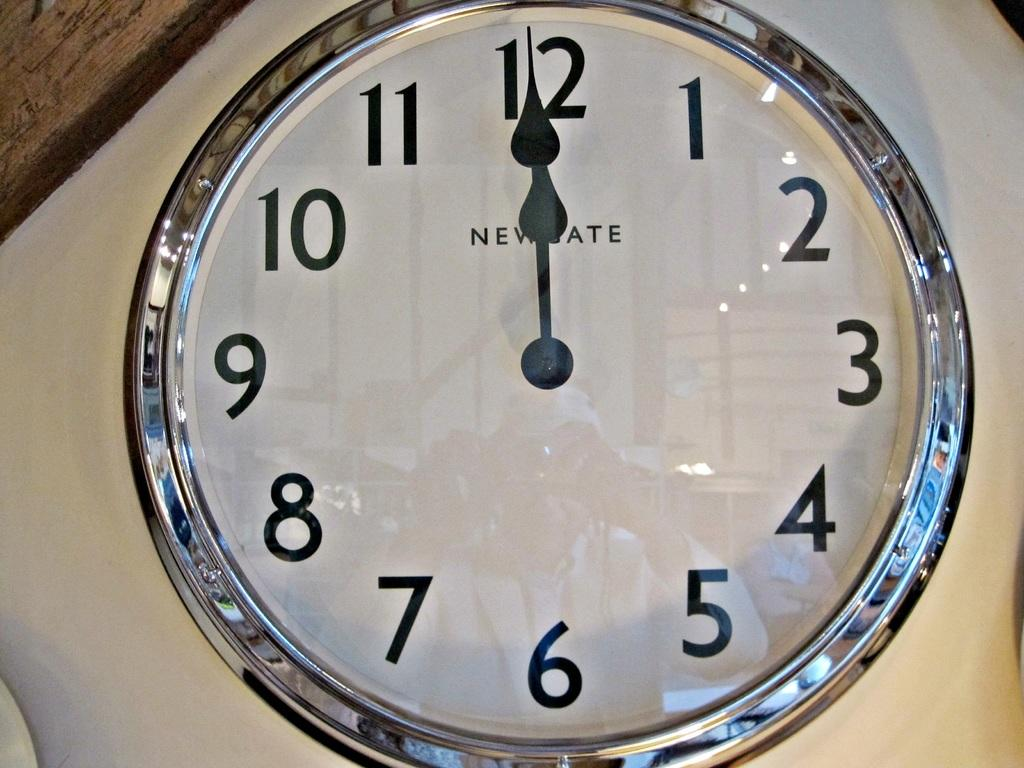<image>
Give a short and clear explanation of the subsequent image. A glass analog wall clock with both hour and minute hands pointing at the 12 